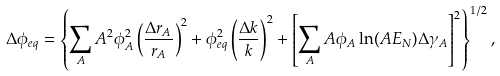<formula> <loc_0><loc_0><loc_500><loc_500>\Delta \phi _ { e q } = \left \{ \sum _ { A } A ^ { 2 } \phi _ { A } ^ { 2 } \left ( \frac { \Delta r _ { A } } { r _ { A } } \right ) ^ { 2 } + \phi _ { e q } ^ { 2 } \left ( \frac { \Delta k } { k } \right ) ^ { 2 } + \left [ \sum _ { A } A \phi _ { A } \ln ( A E _ { N } ) \Delta \gamma _ { A } \right ] ^ { 2 } \right \} ^ { 1 / 2 } ,</formula> 